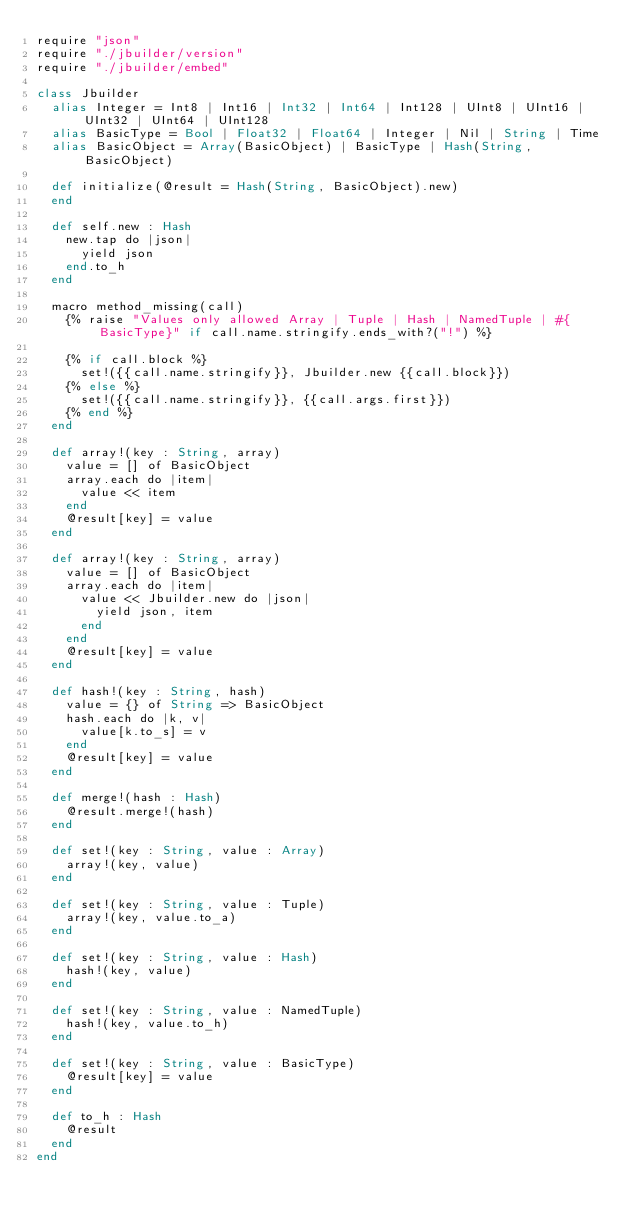Convert code to text. <code><loc_0><loc_0><loc_500><loc_500><_Crystal_>require "json"
require "./jbuilder/version"
require "./jbuilder/embed"

class Jbuilder
  alias Integer = Int8 | Int16 | Int32 | Int64 | Int128 | UInt8 | UInt16 | UInt32 | UInt64 | UInt128
  alias BasicType = Bool | Float32 | Float64 | Integer | Nil | String | Time
  alias BasicObject = Array(BasicObject) | BasicType | Hash(String, BasicObject)

  def initialize(@result = Hash(String, BasicObject).new)
  end

  def self.new : Hash
    new.tap do |json|
      yield json
    end.to_h
  end

  macro method_missing(call)
    {% raise "Values only allowed Array | Tuple | Hash | NamedTuple | #{BasicType}" if call.name.stringify.ends_with?("!") %} 

    {% if call.block %}
      set!({{call.name.stringify}}, Jbuilder.new {{call.block}})
    {% else %}
      set!({{call.name.stringify}}, {{call.args.first}})
    {% end %}
  end

  def array!(key : String, array)
    value = [] of BasicObject
    array.each do |item|
      value << item
    end
    @result[key] = value
  end

  def array!(key : String, array)
    value = [] of BasicObject
    array.each do |item|
      value << Jbuilder.new do |json|
        yield json, item
      end
    end
    @result[key] = value
  end

  def hash!(key : String, hash)
    value = {} of String => BasicObject
    hash.each do |k, v|
      value[k.to_s] = v
    end
    @result[key] = value
  end

  def merge!(hash : Hash)
    @result.merge!(hash)
  end

  def set!(key : String, value : Array)
    array!(key, value)
  end

  def set!(key : String, value : Tuple)
    array!(key, value.to_a)
  end

  def set!(key : String, value : Hash)
    hash!(key, value)
  end

  def set!(key : String, value : NamedTuple)
    hash!(key, value.to_h)
  end

  def set!(key : String, value : BasicType)
    @result[key] = value
  end

  def to_h : Hash
    @result
  end
end
</code> 